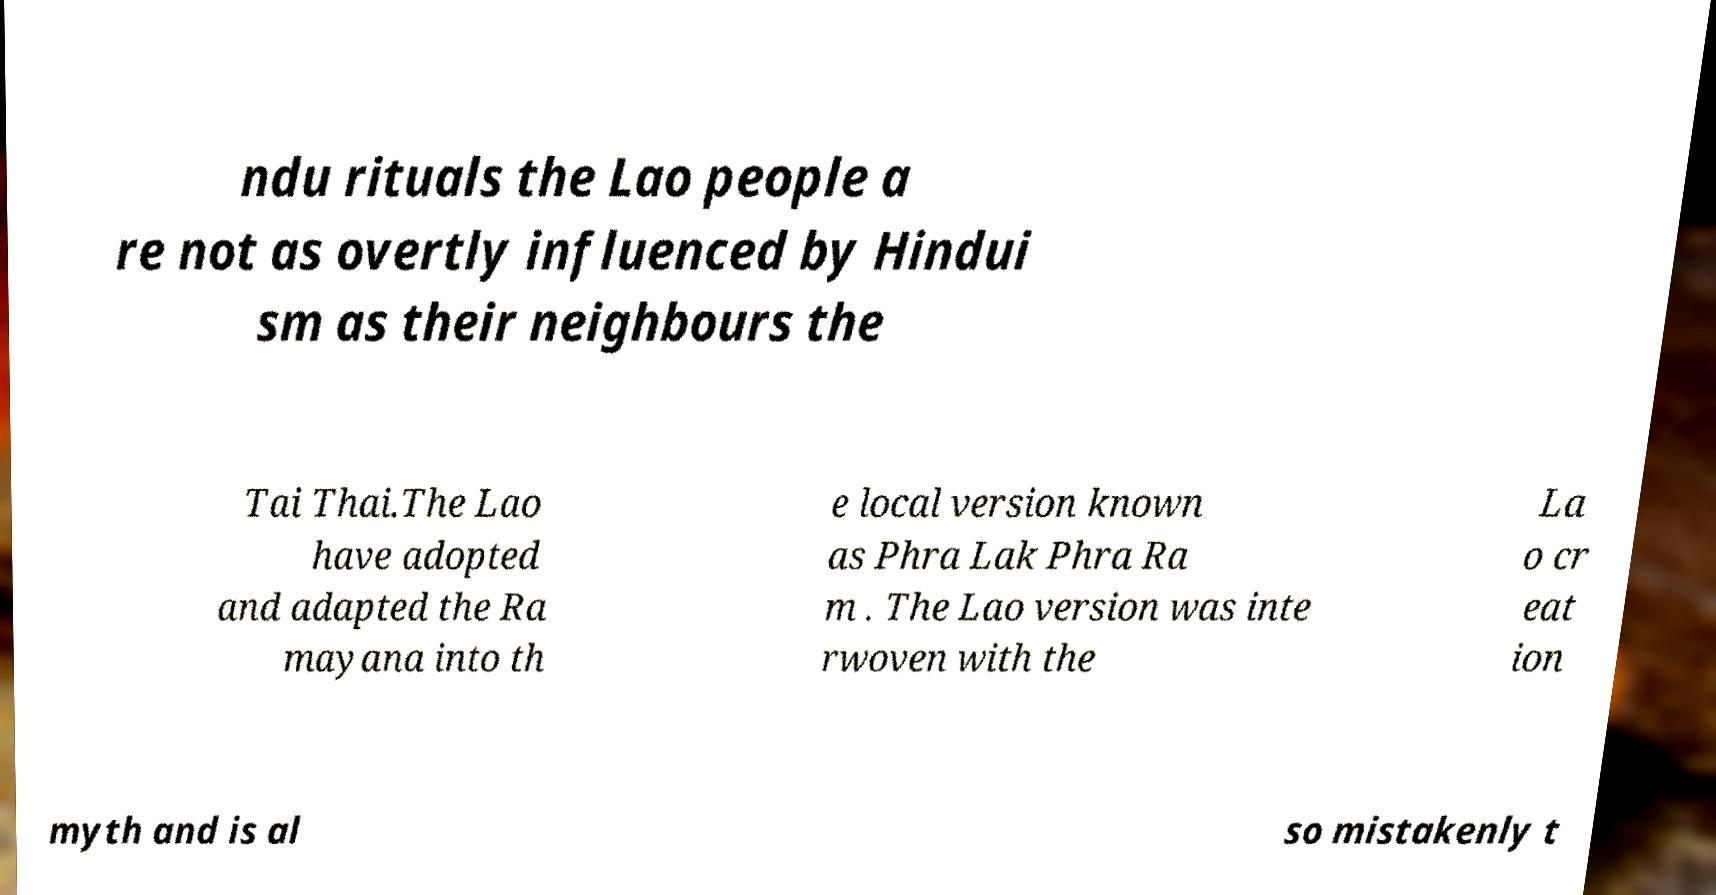Could you extract and type out the text from this image? ndu rituals the Lao people a re not as overtly influenced by Hindui sm as their neighbours the Tai Thai.The Lao have adopted and adapted the Ra mayana into th e local version known as Phra Lak Phra Ra m . The Lao version was inte rwoven with the La o cr eat ion myth and is al so mistakenly t 